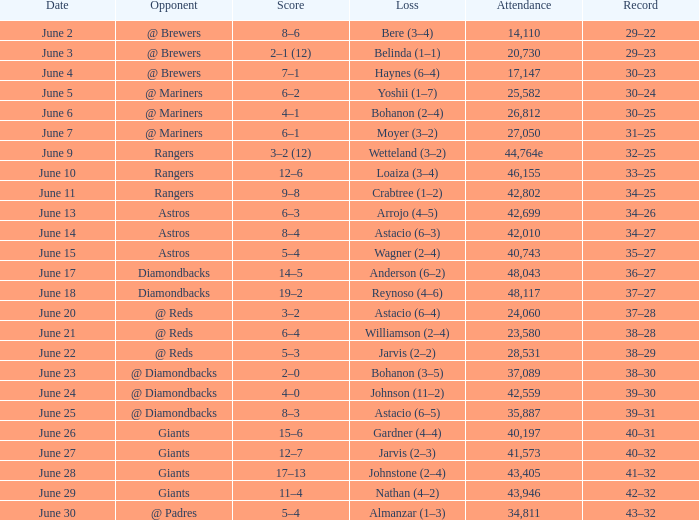Who is scheduled to compete on june 13? Astros. 